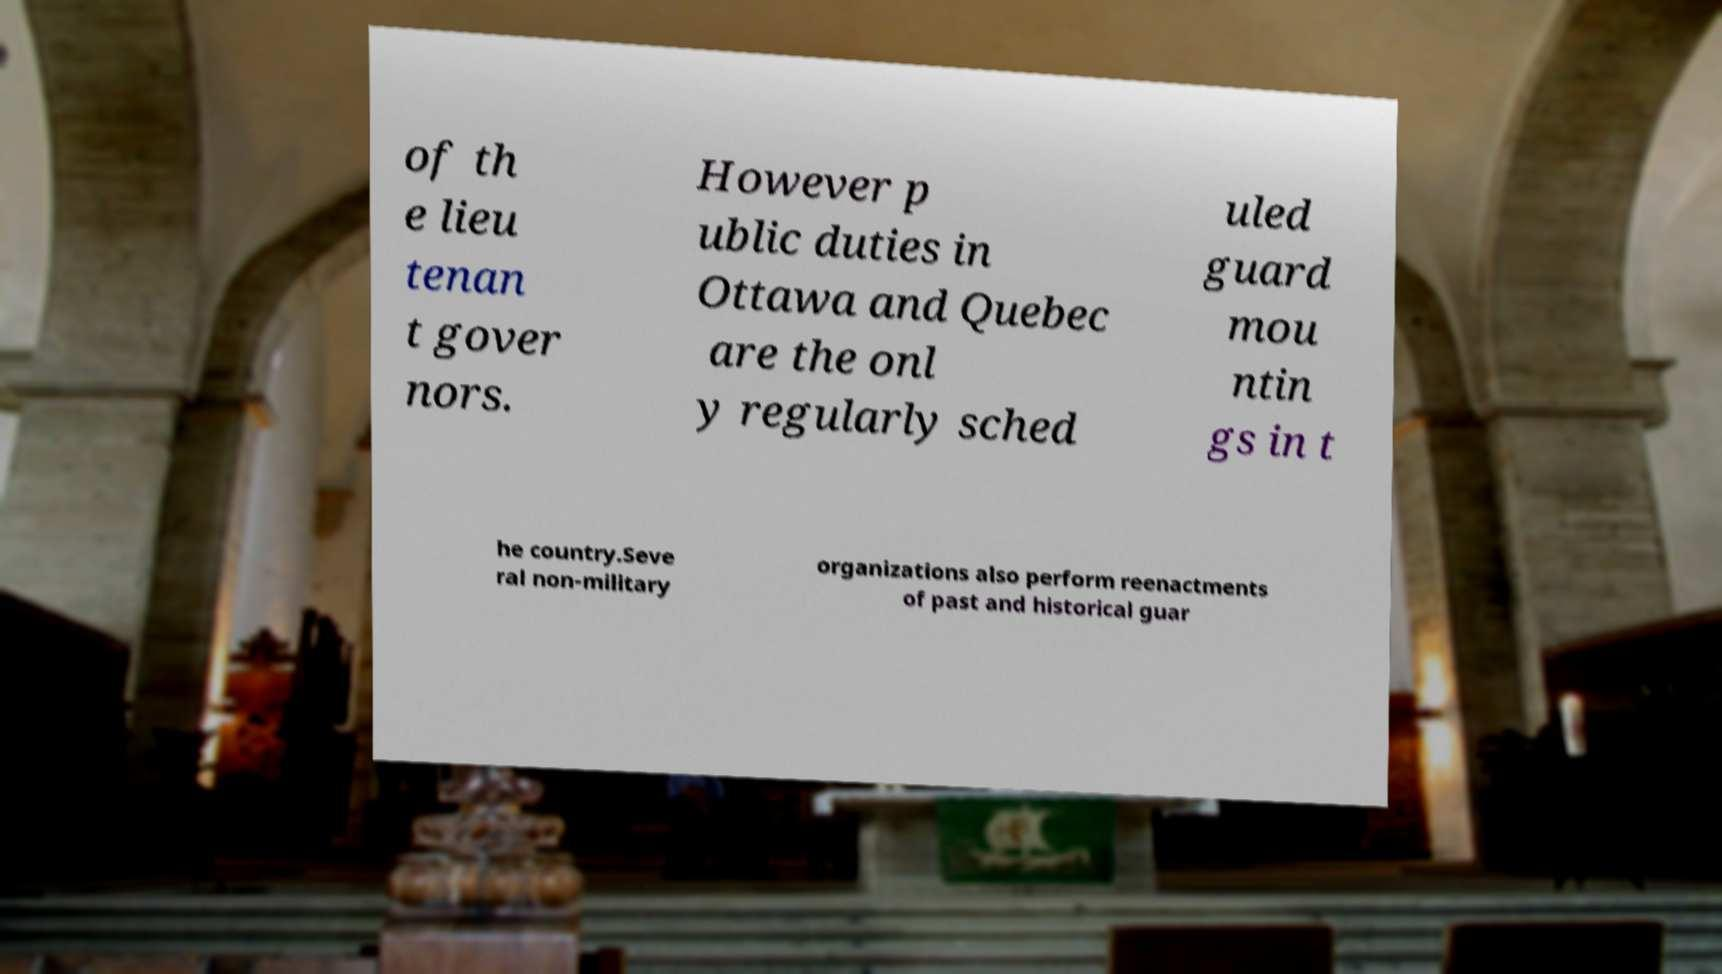Can you read and provide the text displayed in the image?This photo seems to have some interesting text. Can you extract and type it out for me? of th e lieu tenan t gover nors. However p ublic duties in Ottawa and Quebec are the onl y regularly sched uled guard mou ntin gs in t he country.Seve ral non-military organizations also perform reenactments of past and historical guar 